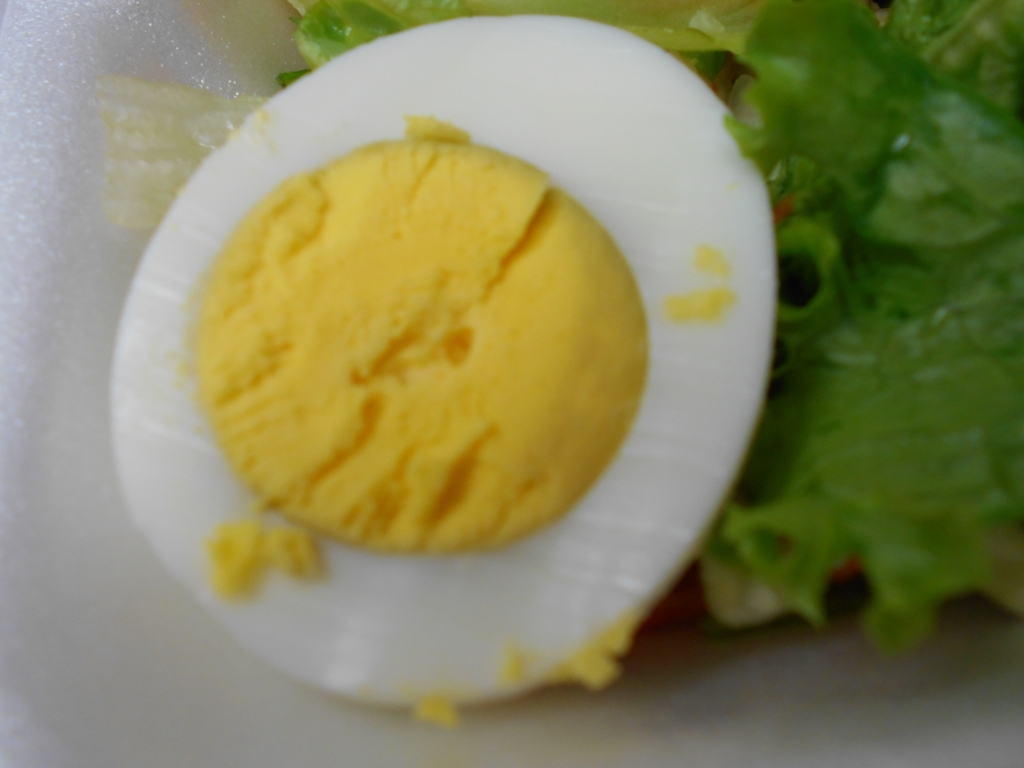Is the image well-focused? The focus of the image is not sharp; the foreground elements such as the egg are slightly blurred, indicating the focus could be improved for better clarity and detail. 